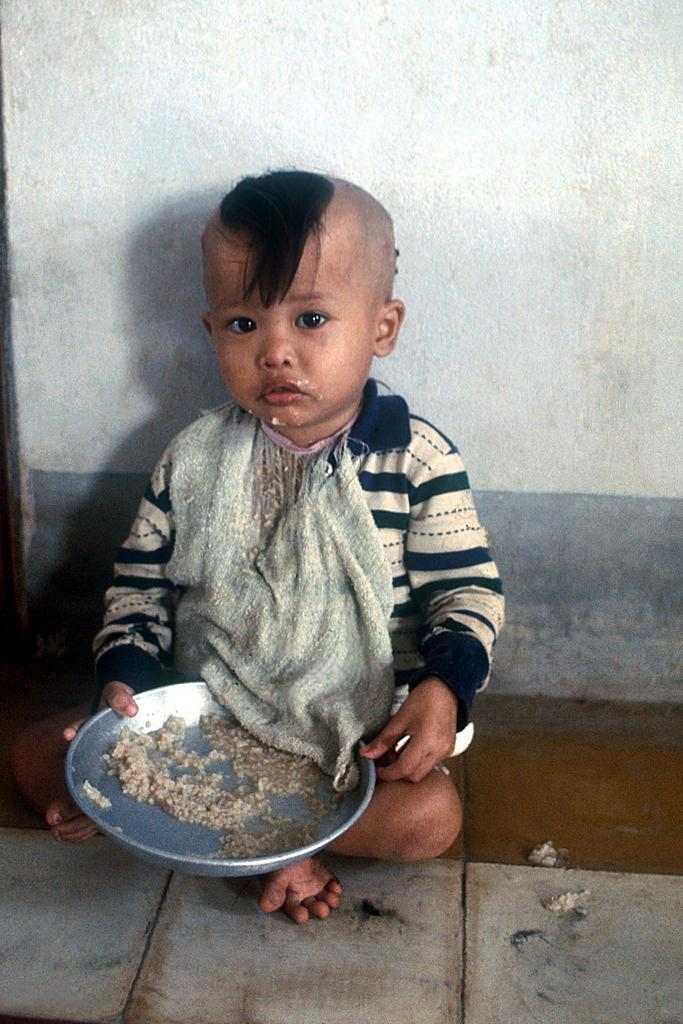What is the boy in the image doing? The boy is sitting in the image. What is the boy holding in the image? The boy is holding a plate in the image. What can be seen behind the boy in the image? There appears to be a wall in the image. What is visible at the bottom of the image? The floor is visible at the bottom of the image. What type of jelly can be seen on the wall in the image? There is no jelly present on the wall in the image. What kind of stone is the boy sitting on in the image? The boy is sitting on a floor, not a stone, in the image. 